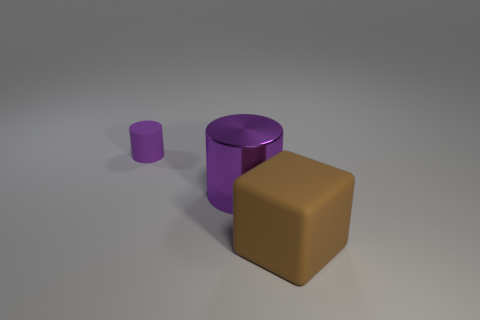Add 2 purple matte cylinders. How many objects exist? 5 Subtract all cubes. How many objects are left? 2 Subtract all big yellow matte balls. Subtract all tiny purple things. How many objects are left? 2 Add 2 metallic things. How many metallic things are left? 3 Add 3 large yellow blocks. How many large yellow blocks exist? 3 Subtract 0 green cubes. How many objects are left? 3 